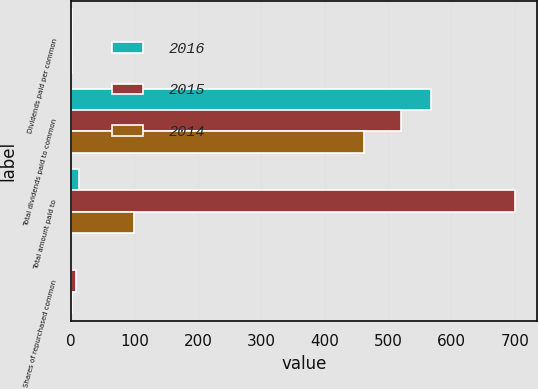<chart> <loc_0><loc_0><loc_500><loc_500><stacked_bar_chart><ecel><fcel>Dividends paid per common<fcel>Total dividends paid to common<fcel>Total amount paid to<fcel>Shares of repurchased common<nl><fcel>2016<fcel>1.52<fcel>568<fcel>13<fcel>0.1<nl><fcel>2015<fcel>1.38<fcel>521<fcel>700<fcel>7.4<nl><fcel>2014<fcel>1.22<fcel>462<fcel>100<fcel>1.3<nl></chart> 